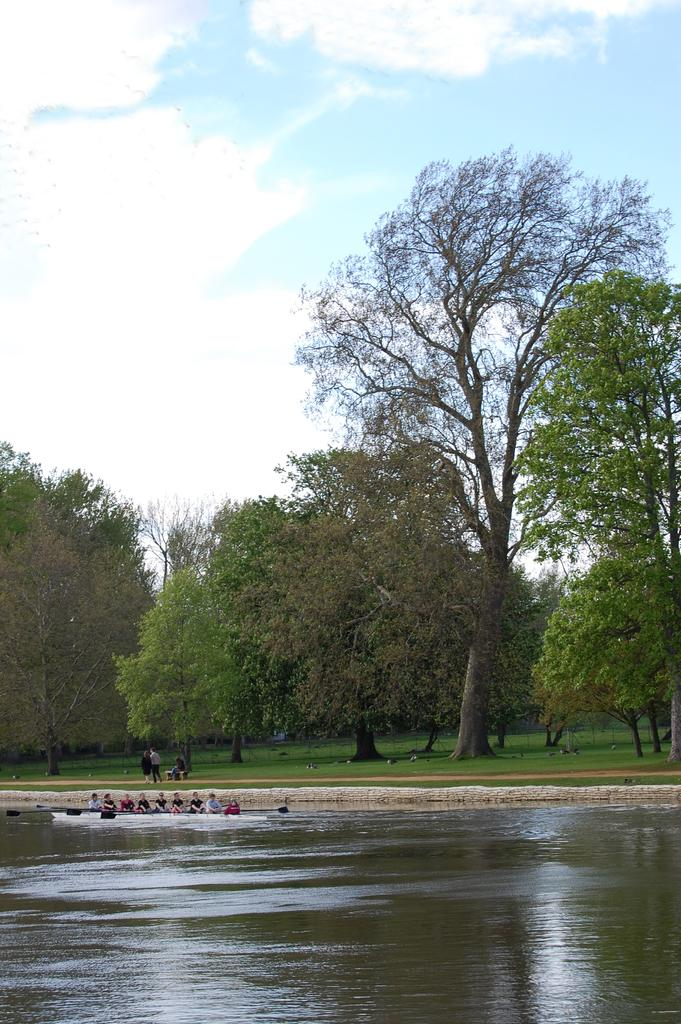What is the main subject of the image? The main subject of the image is a boat on the water. What can be seen on the boat? There are people sitting on the boat. What is visible in the background of the image? There are trees and people in the background. What type of terrain is visible in the image? There is grass on the ground. What part of the natural environment is visible in the image? The sky is visible in the image. Can you tell me how many beads are scattered on the grass in the image? There are no beads present in the image; it features a boat on the water with people sitting on it, surrounded by trees, people, grass, and sky. 